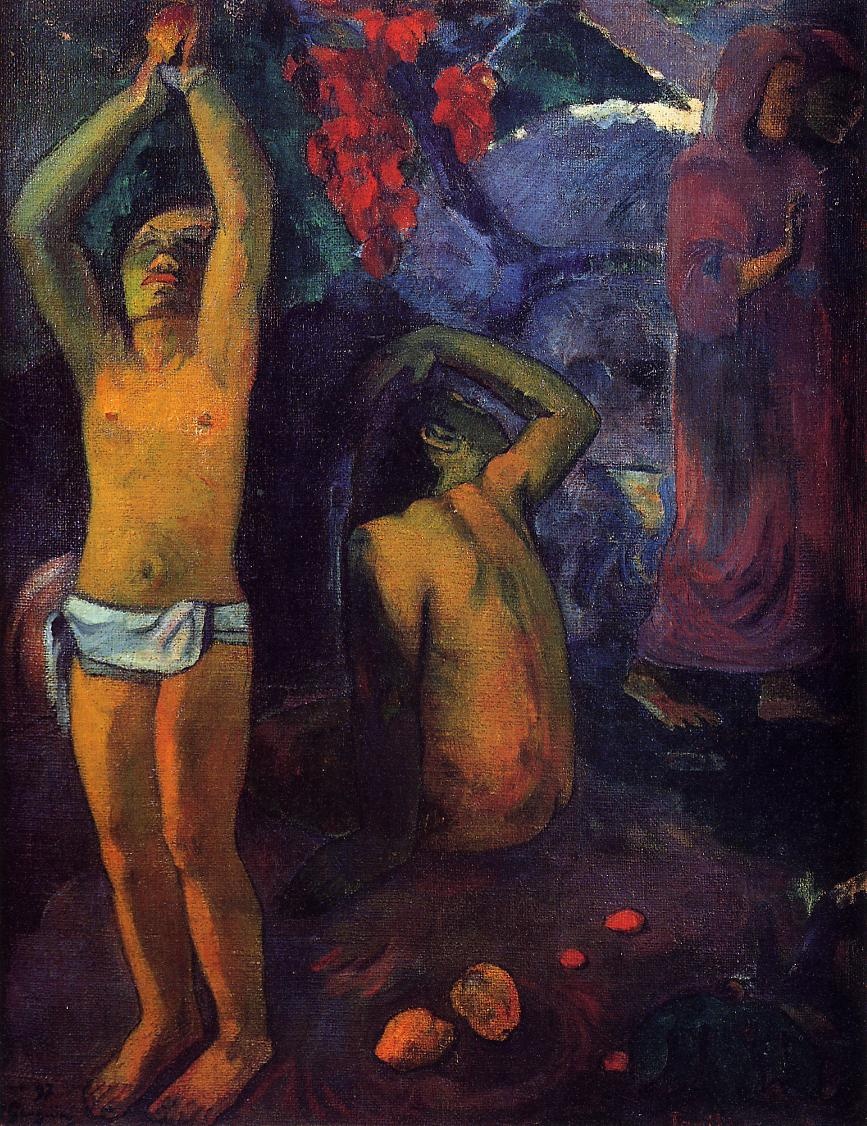Explain the significance of the color scheme used in this painting. The color scheme in this Gauguin painting is pivotal in creating an emotional and thematic depth. The use of dark, earthy tones mixed with vibrant hues like the deep reds and the lush greens enhances the exotic and mystical aura of the Tahitian landscape. These colors do not merely describe the physical setting but also evoke deeper emotions and symbolize the richness of life and the spiritual elements that Gauguin sought to explore. The contrasting colors may also reflect the contrasts between the primitive and the civilized, the earthly and the spiritual, themes central to Gauguin’s works. 